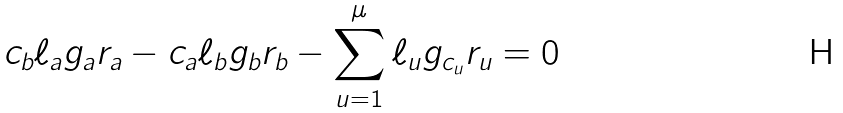<formula> <loc_0><loc_0><loc_500><loc_500>c _ { b } \ell _ { a } g _ { a } r _ { a } - c _ { a } \ell _ { b } g _ { b } r _ { b } - \sum _ { u = 1 } ^ { \mu } \ell _ { u } g _ { c _ { u } } r _ { u } = 0</formula> 